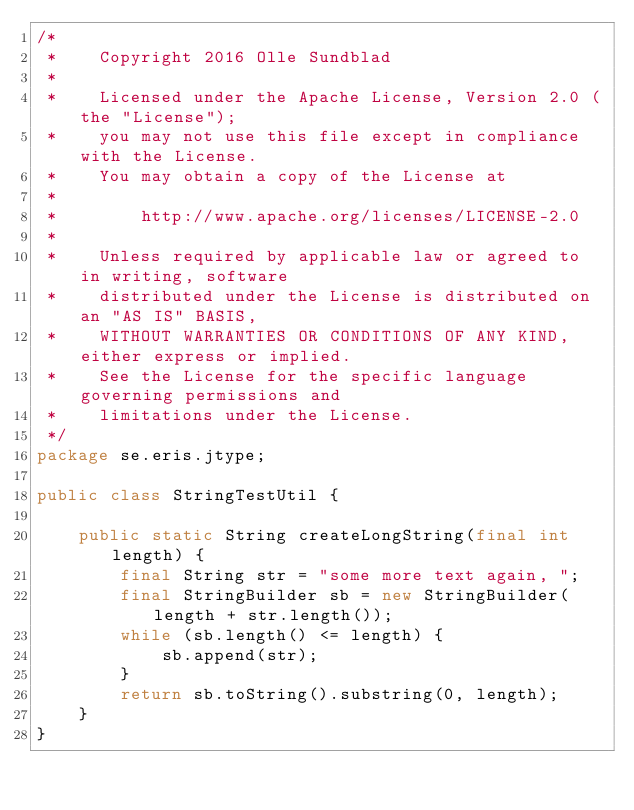<code> <loc_0><loc_0><loc_500><loc_500><_Java_>/*
 *    Copyright 2016 Olle Sundblad
 *
 *    Licensed under the Apache License, Version 2.0 (the "License");
 *    you may not use this file except in compliance with the License.
 *    You may obtain a copy of the License at
 *
 *        http://www.apache.org/licenses/LICENSE-2.0
 *
 *    Unless required by applicable law or agreed to in writing, software
 *    distributed under the License is distributed on an "AS IS" BASIS,
 *    WITHOUT WARRANTIES OR CONDITIONS OF ANY KIND, either express or implied.
 *    See the License for the specific language governing permissions and
 *    limitations under the License.
 */
package se.eris.jtype;

public class StringTestUtil {

    public static String createLongString(final int length) {
        final String str = "some more text again, ";
        final StringBuilder sb = new StringBuilder(length + str.length());
        while (sb.length() <= length) {
            sb.append(str);
        }
        return sb.toString().substring(0, length);
    }
}
</code> 